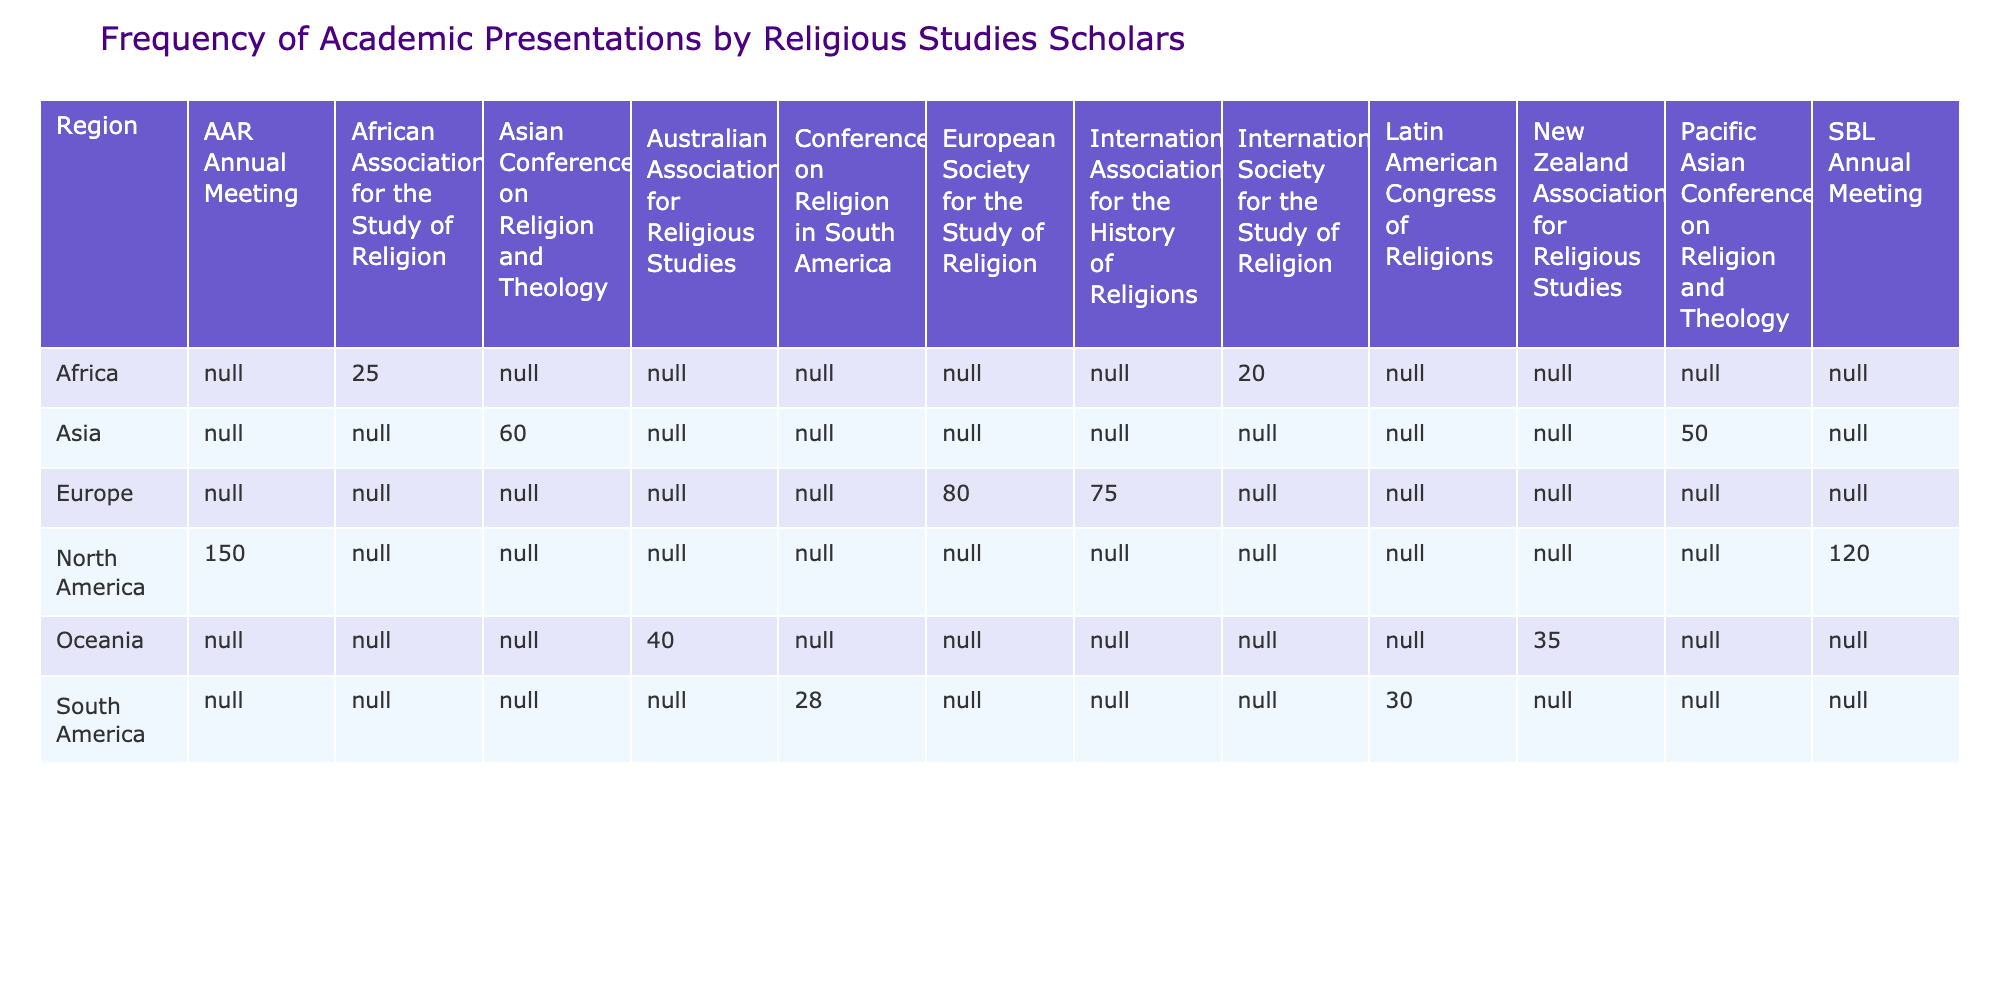What region has the highest number of presentations? From the table, North America has presentations from AAR Annual Meeting (150) and SBL Annual Meeting (120), totaling 270 presentations. This is greater than any other region.
Answer: North America How many presentations were made by scholars in Europe? From the table, the total number of presentations in Europe can be calculated by adding the values: 80 (European Society for the Study of Religion) + 75 (International Association for the History of Religions) = 155.
Answer: 155 Is the total number of presentations from Asia greater than that from Oceania? The total presentations from Asia is 60 (Asian Conference on Religion and Theology) + 50 (Pacific Asian Conference on Religion and Theology) = 110. For Oceania, it’s 40 (Australian Association for Religious Studies) + 35 (New Zealand Association for Religious Studies) = 75. Since 110 is greater than 75, the answer is yes.
Answer: Yes What is the average number of presentations per conference in Africa? In Africa, there are two conferences: African Association for the Study of Religion (25) and International Society for the Study of Religion (20). To find the average, sum the presentations: 25 + 20 = 45, and divide by 2: 45/2 = 22.5.
Answer: 22.5 Which conference had the least number of presentations, and what was that number? By reviewing the table, it can be seen that the conference with the least presentations is the International Society for the Study of Religion with 20 presentations.
Answer: 20 What is the total number of presentations for South America? The total presentations for South America are 30 (Latin American Congress of Religions) + 28 (Conference on Religion in South America) = 58.
Answer: 58 Did any region have an equal number of presentations across its conferences? Upon examining the data, none of the regions show equal numbers of presentations among their conferences. Each conference in each region has a distinct total, hence the answer is no.
Answer: No How many more presentations were made in North America compared to Africa? North America has a total of 270 presentations, while Africa has a total of 45. The difference is calculated as: 270 - 45 = 225.
Answer: 225 What percentage of the total presentations were made in Asia? Asia has a total of 110 presentations and the overall total across all regions is 270 + 155 + 110 + 75 + 45 + 58 = 713 (adding all the totals together from the regions). The percentage is calculated as (110/713)*100, which gives approximately 15.4%.
Answer: 15.4% 